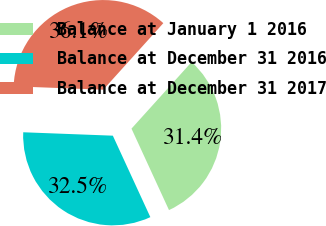Convert chart. <chart><loc_0><loc_0><loc_500><loc_500><pie_chart><fcel>Balance at January 1 2016<fcel>Balance at December 31 2016<fcel>Balance at December 31 2017<nl><fcel>31.44%<fcel>32.47%<fcel>36.08%<nl></chart> 